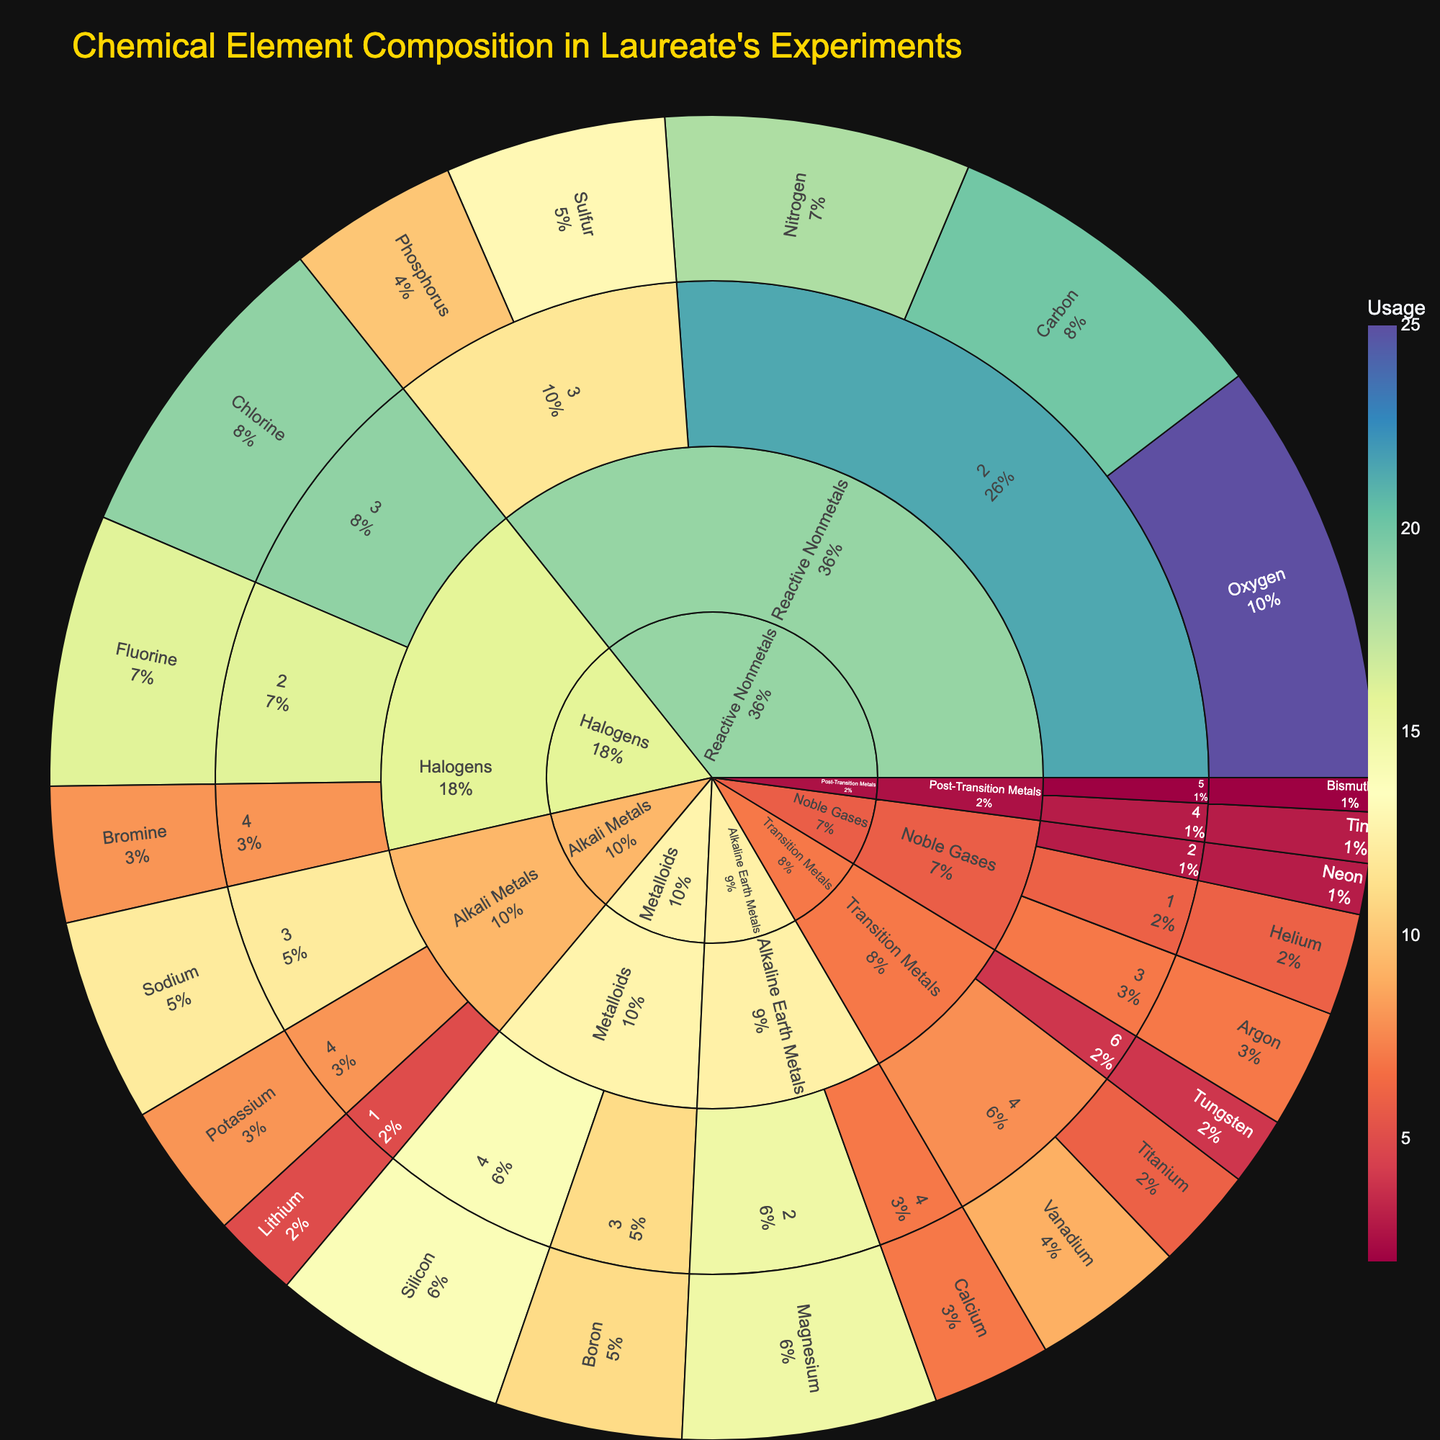What's the title of the plot? The title is located at the top of the figure and it provides a description of what the plot shows.
Answer: Chemical Element Composition in Laureate's Experiments Which element has the highest usage? The element with the largest segment in the sunburst plot represents the highest usage, and hovering over the segment can confirm the value.
Answer: Oxygen How many elements are used from the Metalloids group? Locate the Metalloids segment in the plot and count the individual elements listed under this group.
Answer: 2 What is the total usage of Transition Metals? Identify all elements under the Transition Metals group, then sum their usage values: Titanium (6) + Vanadium (9) + Tungsten (4).
Answer: 19 Among Halogens, which period contains the element with the highest usage? Find the Halogens section and compare the segments of Fluorine (16), Chlorine (19), and Bromine (8). The period with the largest value is 3 (Chlorine).
Answer: 3 Compare the usage of Alkali Metals and Alkaline Earth Metals. Which group has a higher total usage? Sum the usage values for Alkali Metals (Lithium 5, Sodium 12, Potassium 8) = 25 and for Alkaline Earth Metals (Magnesium 15, Calcium 7) = 22. Compare the totals.
Answer: Alkali Metals What percentage of the total usage is contributed by Reactive Nonmetals? Calculate the total usage of Reactive Nonmetals (Carbon 20, Nitrogen 18, Oxygen 25, Phosphorus 10, Sulfur 13) = 86. Then, sum the usage of all elements and compute the percentage (86/206 * 100).
Answer: Approximately 41.75% Which group has the least number of elements used in the experiments? Find the group segments with their internal elements and count them. The group with the fewest elements will have the least segments.
Answer: Noble Gases Is there any element from period 1 that has higher usage than 10? Check elements in period 1: Lithium (5) and Helium (6), both are lower than 10.
Answer: No What is the difference in usage between the most utilized group and the least utilized group? Sum the values for each group to find the total usage: Reactive Nonmetals (86), and the least utilized is Post-Transition Metals (5). Calculate the difference between the highest and lowest total.
Answer: 81 